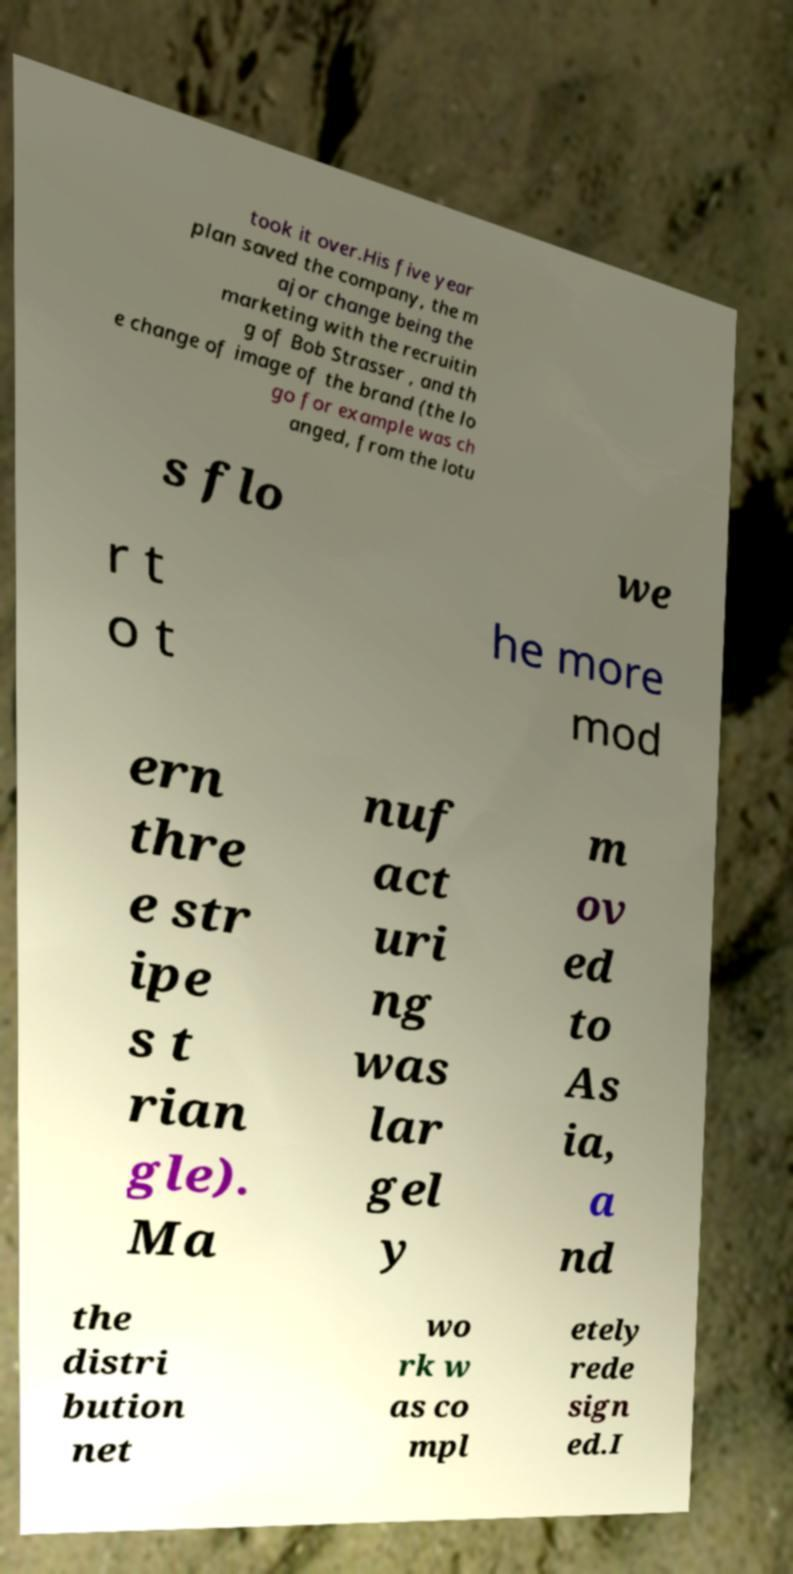Could you extract and type out the text from this image? took it over.His five year plan saved the company, the m ajor change being the marketing with the recruitin g of Bob Strasser , and th e change of image of the brand (the lo go for example was ch anged, from the lotu s flo we r t o t he more mod ern thre e str ipe s t rian gle). Ma nuf act uri ng was lar gel y m ov ed to As ia, a nd the distri bution net wo rk w as co mpl etely rede sign ed.I 